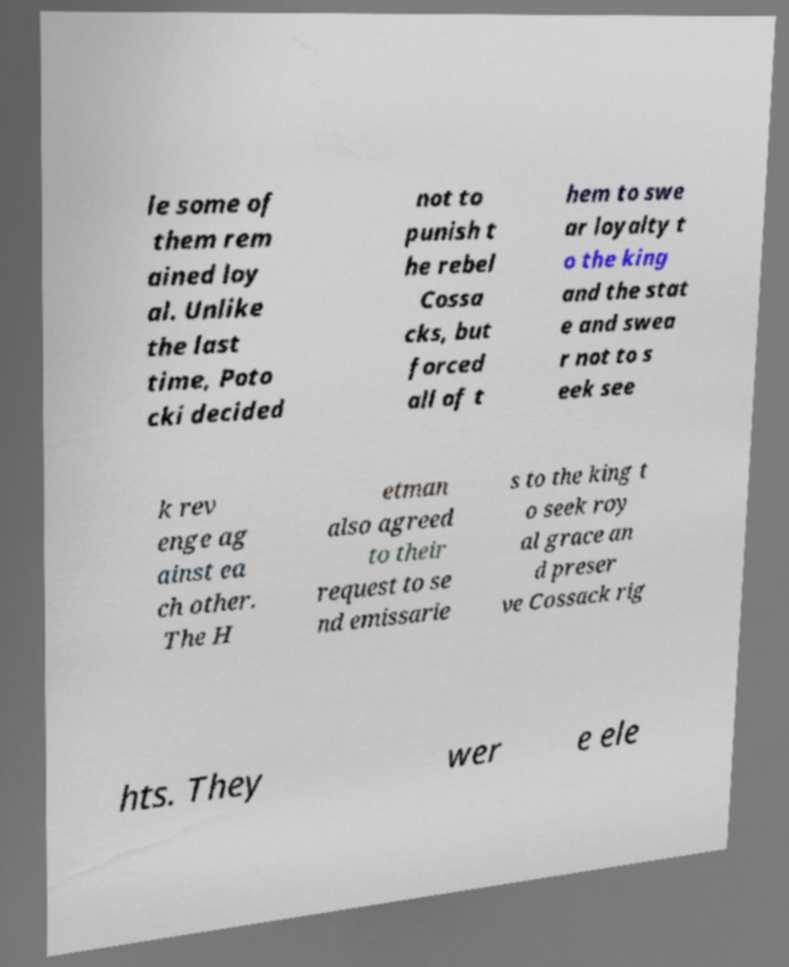There's text embedded in this image that I need extracted. Can you transcribe it verbatim? le some of them rem ained loy al. Unlike the last time, Poto cki decided not to punish t he rebel Cossa cks, but forced all of t hem to swe ar loyalty t o the king and the stat e and swea r not to s eek see k rev enge ag ainst ea ch other. The H etman also agreed to their request to se nd emissarie s to the king t o seek roy al grace an d preser ve Cossack rig hts. They wer e ele 